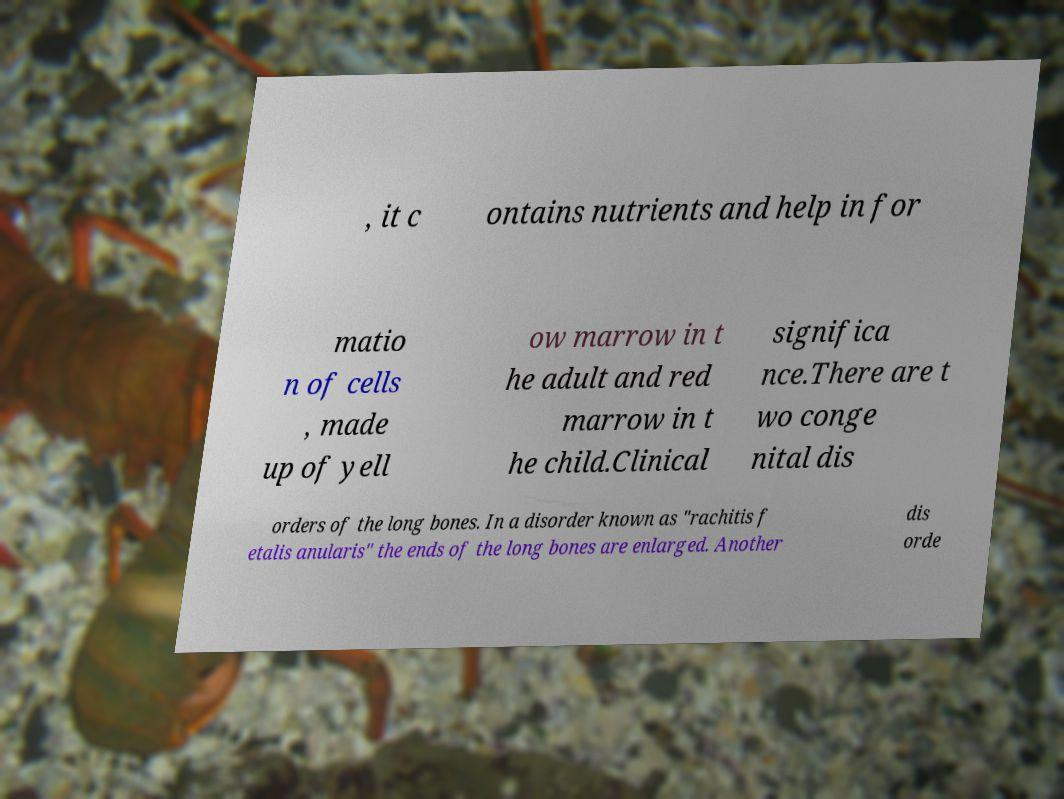For documentation purposes, I need the text within this image transcribed. Could you provide that? , it c ontains nutrients and help in for matio n of cells , made up of yell ow marrow in t he adult and red marrow in t he child.Clinical significa nce.There are t wo conge nital dis orders of the long bones. In a disorder known as "rachitis f etalis anularis" the ends of the long bones are enlarged. Another dis orde 